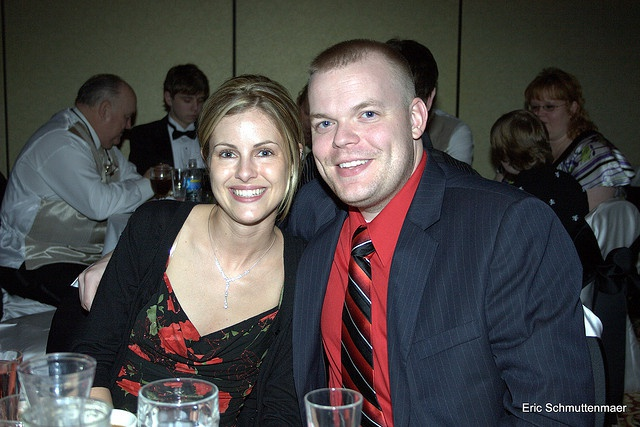Describe the objects in this image and their specific colors. I can see people in black, lightgray, and darkgray tones, people in black, lightgray, and tan tones, people in black and gray tones, people in black and purple tones, and people in black and gray tones in this image. 